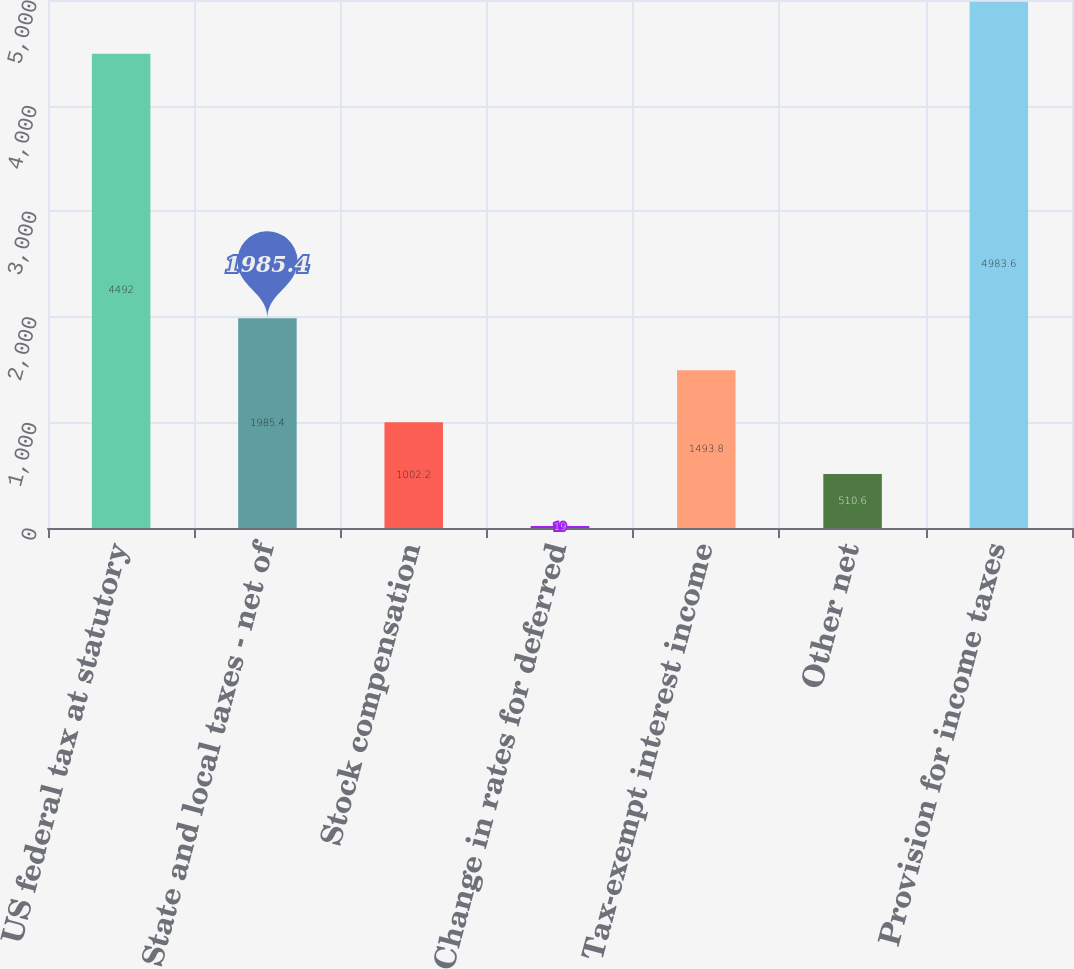<chart> <loc_0><loc_0><loc_500><loc_500><bar_chart><fcel>US federal tax at statutory<fcel>State and local taxes - net of<fcel>Stock compensation<fcel>Change in rates for deferred<fcel>Tax-exempt interest income<fcel>Other net<fcel>Provision for income taxes<nl><fcel>4492<fcel>1985.4<fcel>1002.2<fcel>19<fcel>1493.8<fcel>510.6<fcel>4983.6<nl></chart> 